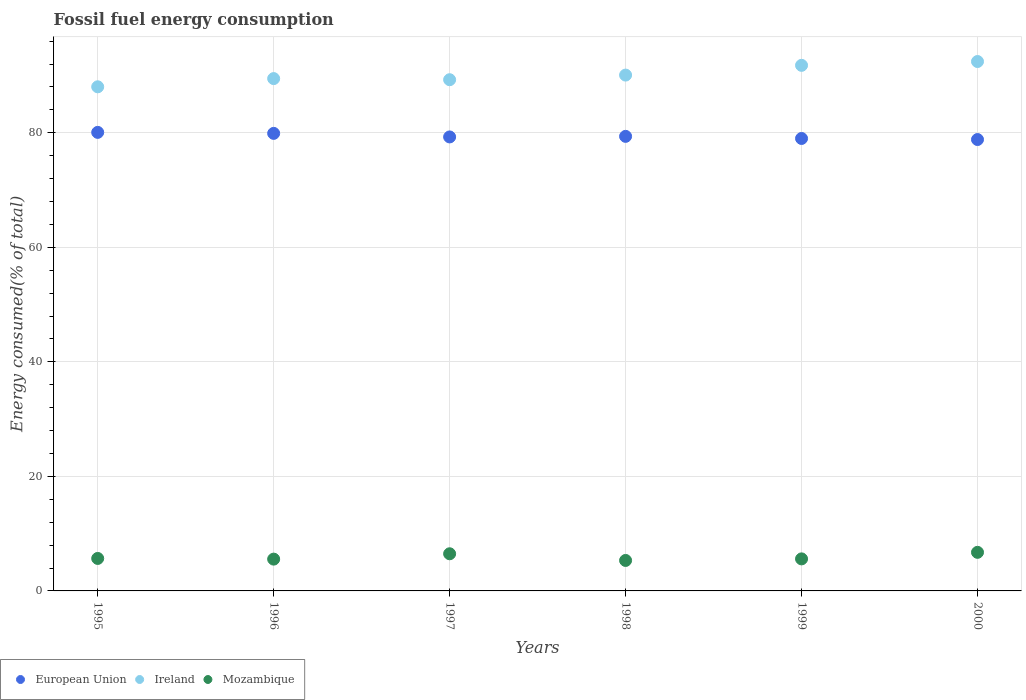How many different coloured dotlines are there?
Your answer should be very brief. 3. What is the percentage of energy consumed in Mozambique in 1998?
Keep it short and to the point. 5.32. Across all years, what is the maximum percentage of energy consumed in Ireland?
Provide a succinct answer. 92.45. Across all years, what is the minimum percentage of energy consumed in European Union?
Make the answer very short. 78.82. In which year was the percentage of energy consumed in Mozambique maximum?
Your answer should be compact. 2000. What is the total percentage of energy consumed in Mozambique in the graph?
Provide a short and direct response. 35.37. What is the difference between the percentage of energy consumed in European Union in 1996 and that in 2000?
Offer a very short reply. 1.07. What is the difference between the percentage of energy consumed in European Union in 1999 and the percentage of energy consumed in Mozambique in 1996?
Ensure brevity in your answer.  73.46. What is the average percentage of energy consumed in European Union per year?
Your answer should be very brief. 79.41. In the year 1999, what is the difference between the percentage of energy consumed in Ireland and percentage of energy consumed in Mozambique?
Your answer should be compact. 86.18. In how many years, is the percentage of energy consumed in European Union greater than 56 %?
Offer a terse response. 6. What is the ratio of the percentage of energy consumed in European Union in 1995 to that in 1997?
Provide a succinct answer. 1.01. Is the percentage of energy consumed in Mozambique in 1995 less than that in 1997?
Your answer should be very brief. Yes. What is the difference between the highest and the second highest percentage of energy consumed in Mozambique?
Give a very brief answer. 0.25. What is the difference between the highest and the lowest percentage of energy consumed in Mozambique?
Ensure brevity in your answer.  1.42. In how many years, is the percentage of energy consumed in Ireland greater than the average percentage of energy consumed in Ireland taken over all years?
Make the answer very short. 2. Is it the case that in every year, the sum of the percentage of energy consumed in European Union and percentage of energy consumed in Mozambique  is greater than the percentage of energy consumed in Ireland?
Offer a very short reply. No. Does the percentage of energy consumed in European Union monotonically increase over the years?
Provide a succinct answer. No. Is the percentage of energy consumed in European Union strictly greater than the percentage of energy consumed in Mozambique over the years?
Your answer should be compact. Yes. Is the percentage of energy consumed in Ireland strictly less than the percentage of energy consumed in European Union over the years?
Your answer should be compact. No. How many dotlines are there?
Provide a short and direct response. 3. How many years are there in the graph?
Give a very brief answer. 6. Are the values on the major ticks of Y-axis written in scientific E-notation?
Offer a very short reply. No. How are the legend labels stacked?
Your answer should be very brief. Horizontal. What is the title of the graph?
Your response must be concise. Fossil fuel energy consumption. What is the label or title of the Y-axis?
Make the answer very short. Energy consumed(% of total). What is the Energy consumed(% of total) in European Union in 1995?
Your answer should be very brief. 80.07. What is the Energy consumed(% of total) of Ireland in 1995?
Make the answer very short. 88.03. What is the Energy consumed(% of total) in Mozambique in 1995?
Your answer should be very brief. 5.67. What is the Energy consumed(% of total) in European Union in 1996?
Make the answer very short. 79.9. What is the Energy consumed(% of total) in Ireland in 1996?
Offer a very short reply. 89.46. What is the Energy consumed(% of total) of Mozambique in 1996?
Make the answer very short. 5.55. What is the Energy consumed(% of total) of European Union in 1997?
Give a very brief answer. 79.28. What is the Energy consumed(% of total) of Ireland in 1997?
Provide a succinct answer. 89.27. What is the Energy consumed(% of total) of Mozambique in 1997?
Keep it short and to the point. 6.49. What is the Energy consumed(% of total) in European Union in 1998?
Your response must be concise. 79.38. What is the Energy consumed(% of total) in Ireland in 1998?
Your answer should be very brief. 90.08. What is the Energy consumed(% of total) in Mozambique in 1998?
Provide a succinct answer. 5.32. What is the Energy consumed(% of total) in European Union in 1999?
Your response must be concise. 79.01. What is the Energy consumed(% of total) in Ireland in 1999?
Your response must be concise. 91.78. What is the Energy consumed(% of total) in Mozambique in 1999?
Keep it short and to the point. 5.6. What is the Energy consumed(% of total) of European Union in 2000?
Keep it short and to the point. 78.82. What is the Energy consumed(% of total) in Ireland in 2000?
Offer a very short reply. 92.45. What is the Energy consumed(% of total) of Mozambique in 2000?
Your answer should be compact. 6.74. Across all years, what is the maximum Energy consumed(% of total) in European Union?
Your answer should be very brief. 80.07. Across all years, what is the maximum Energy consumed(% of total) of Ireland?
Provide a short and direct response. 92.45. Across all years, what is the maximum Energy consumed(% of total) of Mozambique?
Make the answer very short. 6.74. Across all years, what is the minimum Energy consumed(% of total) of European Union?
Make the answer very short. 78.82. Across all years, what is the minimum Energy consumed(% of total) in Ireland?
Your response must be concise. 88.03. Across all years, what is the minimum Energy consumed(% of total) of Mozambique?
Keep it short and to the point. 5.32. What is the total Energy consumed(% of total) in European Union in the graph?
Ensure brevity in your answer.  476.45. What is the total Energy consumed(% of total) of Ireland in the graph?
Keep it short and to the point. 541.06. What is the total Energy consumed(% of total) of Mozambique in the graph?
Provide a succinct answer. 35.37. What is the difference between the Energy consumed(% of total) of European Union in 1995 and that in 1996?
Your response must be concise. 0.17. What is the difference between the Energy consumed(% of total) of Ireland in 1995 and that in 1996?
Offer a very short reply. -1.43. What is the difference between the Energy consumed(% of total) in Mozambique in 1995 and that in 1996?
Your answer should be very brief. 0.12. What is the difference between the Energy consumed(% of total) in European Union in 1995 and that in 1997?
Offer a very short reply. 0.8. What is the difference between the Energy consumed(% of total) of Ireland in 1995 and that in 1997?
Make the answer very short. -1.24. What is the difference between the Energy consumed(% of total) of Mozambique in 1995 and that in 1997?
Your answer should be compact. -0.82. What is the difference between the Energy consumed(% of total) of European Union in 1995 and that in 1998?
Your response must be concise. 0.7. What is the difference between the Energy consumed(% of total) in Ireland in 1995 and that in 1998?
Offer a terse response. -2.05. What is the difference between the Energy consumed(% of total) of Mozambique in 1995 and that in 1998?
Your answer should be compact. 0.35. What is the difference between the Energy consumed(% of total) of European Union in 1995 and that in 1999?
Your response must be concise. 1.06. What is the difference between the Energy consumed(% of total) in Ireland in 1995 and that in 1999?
Your answer should be compact. -3.75. What is the difference between the Energy consumed(% of total) in Mozambique in 1995 and that in 1999?
Give a very brief answer. 0.08. What is the difference between the Energy consumed(% of total) of European Union in 1995 and that in 2000?
Offer a very short reply. 1.25. What is the difference between the Energy consumed(% of total) in Ireland in 1995 and that in 2000?
Your answer should be very brief. -4.42. What is the difference between the Energy consumed(% of total) of Mozambique in 1995 and that in 2000?
Give a very brief answer. -1.07. What is the difference between the Energy consumed(% of total) in European Union in 1996 and that in 1997?
Offer a very short reply. 0.62. What is the difference between the Energy consumed(% of total) in Ireland in 1996 and that in 1997?
Your answer should be very brief. 0.2. What is the difference between the Energy consumed(% of total) in Mozambique in 1996 and that in 1997?
Your response must be concise. -0.94. What is the difference between the Energy consumed(% of total) of European Union in 1996 and that in 1998?
Offer a terse response. 0.52. What is the difference between the Energy consumed(% of total) in Ireland in 1996 and that in 1998?
Your response must be concise. -0.61. What is the difference between the Energy consumed(% of total) of Mozambique in 1996 and that in 1998?
Your response must be concise. 0.23. What is the difference between the Energy consumed(% of total) in European Union in 1996 and that in 1999?
Give a very brief answer. 0.89. What is the difference between the Energy consumed(% of total) in Ireland in 1996 and that in 1999?
Your answer should be compact. -2.31. What is the difference between the Energy consumed(% of total) in Mozambique in 1996 and that in 1999?
Your response must be concise. -0.04. What is the difference between the Energy consumed(% of total) in European Union in 1996 and that in 2000?
Provide a short and direct response. 1.07. What is the difference between the Energy consumed(% of total) of Ireland in 1996 and that in 2000?
Your answer should be compact. -2.98. What is the difference between the Energy consumed(% of total) of Mozambique in 1996 and that in 2000?
Your answer should be very brief. -1.19. What is the difference between the Energy consumed(% of total) in European Union in 1997 and that in 1998?
Give a very brief answer. -0.1. What is the difference between the Energy consumed(% of total) of Ireland in 1997 and that in 1998?
Ensure brevity in your answer.  -0.81. What is the difference between the Energy consumed(% of total) in Mozambique in 1997 and that in 1998?
Your answer should be very brief. 1.17. What is the difference between the Energy consumed(% of total) of European Union in 1997 and that in 1999?
Offer a very short reply. 0.27. What is the difference between the Energy consumed(% of total) in Ireland in 1997 and that in 1999?
Keep it short and to the point. -2.51. What is the difference between the Energy consumed(% of total) of Mozambique in 1997 and that in 1999?
Provide a succinct answer. 0.89. What is the difference between the Energy consumed(% of total) of European Union in 1997 and that in 2000?
Your response must be concise. 0.45. What is the difference between the Energy consumed(% of total) of Ireland in 1997 and that in 2000?
Your answer should be compact. -3.18. What is the difference between the Energy consumed(% of total) of Mozambique in 1997 and that in 2000?
Give a very brief answer. -0.25. What is the difference between the Energy consumed(% of total) in European Union in 1998 and that in 1999?
Provide a short and direct response. 0.37. What is the difference between the Energy consumed(% of total) of Ireland in 1998 and that in 1999?
Offer a terse response. -1.7. What is the difference between the Energy consumed(% of total) in Mozambique in 1998 and that in 1999?
Offer a very short reply. -0.27. What is the difference between the Energy consumed(% of total) in European Union in 1998 and that in 2000?
Keep it short and to the point. 0.55. What is the difference between the Energy consumed(% of total) of Ireland in 1998 and that in 2000?
Your answer should be very brief. -2.37. What is the difference between the Energy consumed(% of total) of Mozambique in 1998 and that in 2000?
Your answer should be very brief. -1.42. What is the difference between the Energy consumed(% of total) in European Union in 1999 and that in 2000?
Offer a terse response. 0.18. What is the difference between the Energy consumed(% of total) of Ireland in 1999 and that in 2000?
Ensure brevity in your answer.  -0.67. What is the difference between the Energy consumed(% of total) in Mozambique in 1999 and that in 2000?
Ensure brevity in your answer.  -1.14. What is the difference between the Energy consumed(% of total) in European Union in 1995 and the Energy consumed(% of total) in Ireland in 1996?
Your response must be concise. -9.39. What is the difference between the Energy consumed(% of total) of European Union in 1995 and the Energy consumed(% of total) of Mozambique in 1996?
Provide a short and direct response. 74.52. What is the difference between the Energy consumed(% of total) in Ireland in 1995 and the Energy consumed(% of total) in Mozambique in 1996?
Your answer should be very brief. 82.48. What is the difference between the Energy consumed(% of total) in European Union in 1995 and the Energy consumed(% of total) in Ireland in 1997?
Give a very brief answer. -9.2. What is the difference between the Energy consumed(% of total) in European Union in 1995 and the Energy consumed(% of total) in Mozambique in 1997?
Ensure brevity in your answer.  73.58. What is the difference between the Energy consumed(% of total) of Ireland in 1995 and the Energy consumed(% of total) of Mozambique in 1997?
Give a very brief answer. 81.54. What is the difference between the Energy consumed(% of total) of European Union in 1995 and the Energy consumed(% of total) of Ireland in 1998?
Ensure brevity in your answer.  -10. What is the difference between the Energy consumed(% of total) in European Union in 1995 and the Energy consumed(% of total) in Mozambique in 1998?
Ensure brevity in your answer.  74.75. What is the difference between the Energy consumed(% of total) of Ireland in 1995 and the Energy consumed(% of total) of Mozambique in 1998?
Your answer should be very brief. 82.71. What is the difference between the Energy consumed(% of total) in European Union in 1995 and the Energy consumed(% of total) in Ireland in 1999?
Your answer should be compact. -11.71. What is the difference between the Energy consumed(% of total) of European Union in 1995 and the Energy consumed(% of total) of Mozambique in 1999?
Your answer should be very brief. 74.48. What is the difference between the Energy consumed(% of total) of Ireland in 1995 and the Energy consumed(% of total) of Mozambique in 1999?
Make the answer very short. 82.43. What is the difference between the Energy consumed(% of total) of European Union in 1995 and the Energy consumed(% of total) of Ireland in 2000?
Provide a succinct answer. -12.37. What is the difference between the Energy consumed(% of total) in European Union in 1995 and the Energy consumed(% of total) in Mozambique in 2000?
Your response must be concise. 73.33. What is the difference between the Energy consumed(% of total) of Ireland in 1995 and the Energy consumed(% of total) of Mozambique in 2000?
Ensure brevity in your answer.  81.29. What is the difference between the Energy consumed(% of total) in European Union in 1996 and the Energy consumed(% of total) in Ireland in 1997?
Your answer should be very brief. -9.37. What is the difference between the Energy consumed(% of total) of European Union in 1996 and the Energy consumed(% of total) of Mozambique in 1997?
Your answer should be compact. 73.41. What is the difference between the Energy consumed(% of total) in Ireland in 1996 and the Energy consumed(% of total) in Mozambique in 1997?
Offer a very short reply. 82.98. What is the difference between the Energy consumed(% of total) of European Union in 1996 and the Energy consumed(% of total) of Ireland in 1998?
Offer a very short reply. -10.18. What is the difference between the Energy consumed(% of total) in European Union in 1996 and the Energy consumed(% of total) in Mozambique in 1998?
Your response must be concise. 74.58. What is the difference between the Energy consumed(% of total) in Ireland in 1996 and the Energy consumed(% of total) in Mozambique in 1998?
Ensure brevity in your answer.  84.14. What is the difference between the Energy consumed(% of total) of European Union in 1996 and the Energy consumed(% of total) of Ireland in 1999?
Your answer should be compact. -11.88. What is the difference between the Energy consumed(% of total) of European Union in 1996 and the Energy consumed(% of total) of Mozambique in 1999?
Keep it short and to the point. 74.3. What is the difference between the Energy consumed(% of total) in Ireland in 1996 and the Energy consumed(% of total) in Mozambique in 1999?
Provide a succinct answer. 83.87. What is the difference between the Energy consumed(% of total) in European Union in 1996 and the Energy consumed(% of total) in Ireland in 2000?
Your answer should be compact. -12.55. What is the difference between the Energy consumed(% of total) in European Union in 1996 and the Energy consumed(% of total) in Mozambique in 2000?
Your response must be concise. 73.16. What is the difference between the Energy consumed(% of total) of Ireland in 1996 and the Energy consumed(% of total) of Mozambique in 2000?
Offer a very short reply. 82.73. What is the difference between the Energy consumed(% of total) in European Union in 1997 and the Energy consumed(% of total) in Ireland in 1998?
Your answer should be very brief. -10.8. What is the difference between the Energy consumed(% of total) in European Union in 1997 and the Energy consumed(% of total) in Mozambique in 1998?
Offer a terse response. 73.95. What is the difference between the Energy consumed(% of total) in Ireland in 1997 and the Energy consumed(% of total) in Mozambique in 1998?
Ensure brevity in your answer.  83.95. What is the difference between the Energy consumed(% of total) in European Union in 1997 and the Energy consumed(% of total) in Ireland in 1999?
Your response must be concise. -12.5. What is the difference between the Energy consumed(% of total) of European Union in 1997 and the Energy consumed(% of total) of Mozambique in 1999?
Your response must be concise. 73.68. What is the difference between the Energy consumed(% of total) of Ireland in 1997 and the Energy consumed(% of total) of Mozambique in 1999?
Your response must be concise. 83.67. What is the difference between the Energy consumed(% of total) in European Union in 1997 and the Energy consumed(% of total) in Ireland in 2000?
Ensure brevity in your answer.  -13.17. What is the difference between the Energy consumed(% of total) in European Union in 1997 and the Energy consumed(% of total) in Mozambique in 2000?
Provide a succinct answer. 72.54. What is the difference between the Energy consumed(% of total) in Ireland in 1997 and the Energy consumed(% of total) in Mozambique in 2000?
Ensure brevity in your answer.  82.53. What is the difference between the Energy consumed(% of total) in European Union in 1998 and the Energy consumed(% of total) in Ireland in 1999?
Keep it short and to the point. -12.4. What is the difference between the Energy consumed(% of total) of European Union in 1998 and the Energy consumed(% of total) of Mozambique in 1999?
Provide a short and direct response. 73.78. What is the difference between the Energy consumed(% of total) of Ireland in 1998 and the Energy consumed(% of total) of Mozambique in 1999?
Provide a succinct answer. 84.48. What is the difference between the Energy consumed(% of total) of European Union in 1998 and the Energy consumed(% of total) of Ireland in 2000?
Offer a very short reply. -13.07. What is the difference between the Energy consumed(% of total) of European Union in 1998 and the Energy consumed(% of total) of Mozambique in 2000?
Provide a short and direct response. 72.64. What is the difference between the Energy consumed(% of total) of Ireland in 1998 and the Energy consumed(% of total) of Mozambique in 2000?
Ensure brevity in your answer.  83.34. What is the difference between the Energy consumed(% of total) in European Union in 1999 and the Energy consumed(% of total) in Ireland in 2000?
Make the answer very short. -13.44. What is the difference between the Energy consumed(% of total) of European Union in 1999 and the Energy consumed(% of total) of Mozambique in 2000?
Offer a terse response. 72.27. What is the difference between the Energy consumed(% of total) in Ireland in 1999 and the Energy consumed(% of total) in Mozambique in 2000?
Provide a short and direct response. 85.04. What is the average Energy consumed(% of total) of European Union per year?
Provide a succinct answer. 79.41. What is the average Energy consumed(% of total) of Ireland per year?
Offer a terse response. 90.18. What is the average Energy consumed(% of total) in Mozambique per year?
Provide a short and direct response. 5.89. In the year 1995, what is the difference between the Energy consumed(% of total) in European Union and Energy consumed(% of total) in Ireland?
Provide a short and direct response. -7.96. In the year 1995, what is the difference between the Energy consumed(% of total) of European Union and Energy consumed(% of total) of Mozambique?
Give a very brief answer. 74.4. In the year 1995, what is the difference between the Energy consumed(% of total) in Ireland and Energy consumed(% of total) in Mozambique?
Provide a short and direct response. 82.36. In the year 1996, what is the difference between the Energy consumed(% of total) of European Union and Energy consumed(% of total) of Ireland?
Your answer should be very brief. -9.57. In the year 1996, what is the difference between the Energy consumed(% of total) in European Union and Energy consumed(% of total) in Mozambique?
Give a very brief answer. 74.35. In the year 1996, what is the difference between the Energy consumed(% of total) in Ireland and Energy consumed(% of total) in Mozambique?
Give a very brief answer. 83.91. In the year 1997, what is the difference between the Energy consumed(% of total) in European Union and Energy consumed(% of total) in Ireland?
Make the answer very short. -9.99. In the year 1997, what is the difference between the Energy consumed(% of total) of European Union and Energy consumed(% of total) of Mozambique?
Your answer should be very brief. 72.79. In the year 1997, what is the difference between the Energy consumed(% of total) of Ireland and Energy consumed(% of total) of Mozambique?
Offer a terse response. 82.78. In the year 1998, what is the difference between the Energy consumed(% of total) in European Union and Energy consumed(% of total) in Ireland?
Provide a short and direct response. -10.7. In the year 1998, what is the difference between the Energy consumed(% of total) in European Union and Energy consumed(% of total) in Mozambique?
Give a very brief answer. 74.06. In the year 1998, what is the difference between the Energy consumed(% of total) in Ireland and Energy consumed(% of total) in Mozambique?
Provide a short and direct response. 84.75. In the year 1999, what is the difference between the Energy consumed(% of total) of European Union and Energy consumed(% of total) of Ireland?
Keep it short and to the point. -12.77. In the year 1999, what is the difference between the Energy consumed(% of total) in European Union and Energy consumed(% of total) in Mozambique?
Make the answer very short. 73.41. In the year 1999, what is the difference between the Energy consumed(% of total) of Ireland and Energy consumed(% of total) of Mozambique?
Offer a terse response. 86.18. In the year 2000, what is the difference between the Energy consumed(% of total) of European Union and Energy consumed(% of total) of Ireland?
Your answer should be compact. -13.62. In the year 2000, what is the difference between the Energy consumed(% of total) in European Union and Energy consumed(% of total) in Mozambique?
Ensure brevity in your answer.  72.09. In the year 2000, what is the difference between the Energy consumed(% of total) of Ireland and Energy consumed(% of total) of Mozambique?
Give a very brief answer. 85.71. What is the ratio of the Energy consumed(% of total) of European Union in 1995 to that in 1996?
Offer a very short reply. 1. What is the ratio of the Energy consumed(% of total) in Ireland in 1995 to that in 1996?
Offer a terse response. 0.98. What is the ratio of the Energy consumed(% of total) in Mozambique in 1995 to that in 1996?
Your answer should be very brief. 1.02. What is the ratio of the Energy consumed(% of total) of European Union in 1995 to that in 1997?
Make the answer very short. 1.01. What is the ratio of the Energy consumed(% of total) in Ireland in 1995 to that in 1997?
Offer a terse response. 0.99. What is the ratio of the Energy consumed(% of total) in Mozambique in 1995 to that in 1997?
Offer a terse response. 0.87. What is the ratio of the Energy consumed(% of total) of European Union in 1995 to that in 1998?
Your answer should be very brief. 1.01. What is the ratio of the Energy consumed(% of total) in Ireland in 1995 to that in 1998?
Your answer should be very brief. 0.98. What is the ratio of the Energy consumed(% of total) of Mozambique in 1995 to that in 1998?
Your response must be concise. 1.07. What is the ratio of the Energy consumed(% of total) in European Union in 1995 to that in 1999?
Provide a short and direct response. 1.01. What is the ratio of the Energy consumed(% of total) of Ireland in 1995 to that in 1999?
Give a very brief answer. 0.96. What is the ratio of the Energy consumed(% of total) in Mozambique in 1995 to that in 1999?
Ensure brevity in your answer.  1.01. What is the ratio of the Energy consumed(% of total) in European Union in 1995 to that in 2000?
Make the answer very short. 1.02. What is the ratio of the Energy consumed(% of total) of Ireland in 1995 to that in 2000?
Provide a short and direct response. 0.95. What is the ratio of the Energy consumed(% of total) in Mozambique in 1995 to that in 2000?
Offer a very short reply. 0.84. What is the ratio of the Energy consumed(% of total) in Mozambique in 1996 to that in 1997?
Your response must be concise. 0.86. What is the ratio of the Energy consumed(% of total) in European Union in 1996 to that in 1998?
Your response must be concise. 1.01. What is the ratio of the Energy consumed(% of total) in Mozambique in 1996 to that in 1998?
Ensure brevity in your answer.  1.04. What is the ratio of the Energy consumed(% of total) of European Union in 1996 to that in 1999?
Provide a short and direct response. 1.01. What is the ratio of the Energy consumed(% of total) in Ireland in 1996 to that in 1999?
Offer a very short reply. 0.97. What is the ratio of the Energy consumed(% of total) in Mozambique in 1996 to that in 1999?
Offer a terse response. 0.99. What is the ratio of the Energy consumed(% of total) in European Union in 1996 to that in 2000?
Make the answer very short. 1.01. What is the ratio of the Energy consumed(% of total) in Ireland in 1996 to that in 2000?
Your answer should be very brief. 0.97. What is the ratio of the Energy consumed(% of total) in Mozambique in 1996 to that in 2000?
Your response must be concise. 0.82. What is the ratio of the Energy consumed(% of total) in Ireland in 1997 to that in 1998?
Offer a terse response. 0.99. What is the ratio of the Energy consumed(% of total) of Mozambique in 1997 to that in 1998?
Provide a short and direct response. 1.22. What is the ratio of the Energy consumed(% of total) of European Union in 1997 to that in 1999?
Your answer should be compact. 1. What is the ratio of the Energy consumed(% of total) in Ireland in 1997 to that in 1999?
Your response must be concise. 0.97. What is the ratio of the Energy consumed(% of total) of Mozambique in 1997 to that in 1999?
Make the answer very short. 1.16. What is the ratio of the Energy consumed(% of total) of Ireland in 1997 to that in 2000?
Offer a very short reply. 0.97. What is the ratio of the Energy consumed(% of total) in Mozambique in 1997 to that in 2000?
Your response must be concise. 0.96. What is the ratio of the Energy consumed(% of total) in European Union in 1998 to that in 1999?
Give a very brief answer. 1. What is the ratio of the Energy consumed(% of total) in Ireland in 1998 to that in 1999?
Provide a short and direct response. 0.98. What is the ratio of the Energy consumed(% of total) of Mozambique in 1998 to that in 1999?
Offer a terse response. 0.95. What is the ratio of the Energy consumed(% of total) of Ireland in 1998 to that in 2000?
Keep it short and to the point. 0.97. What is the ratio of the Energy consumed(% of total) of Mozambique in 1998 to that in 2000?
Your answer should be compact. 0.79. What is the ratio of the Energy consumed(% of total) of Mozambique in 1999 to that in 2000?
Provide a short and direct response. 0.83. What is the difference between the highest and the second highest Energy consumed(% of total) of European Union?
Your answer should be compact. 0.17. What is the difference between the highest and the second highest Energy consumed(% of total) of Mozambique?
Your response must be concise. 0.25. What is the difference between the highest and the lowest Energy consumed(% of total) of European Union?
Your answer should be compact. 1.25. What is the difference between the highest and the lowest Energy consumed(% of total) of Ireland?
Provide a succinct answer. 4.42. What is the difference between the highest and the lowest Energy consumed(% of total) of Mozambique?
Make the answer very short. 1.42. 